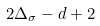Convert formula to latex. <formula><loc_0><loc_0><loc_500><loc_500>2 \Delta _ { \sigma } - d + 2</formula> 